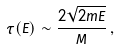<formula> <loc_0><loc_0><loc_500><loc_500>\tau ( E ) \sim \frac { 2 \sqrt { 2 m E } } { M } \, ,</formula> 